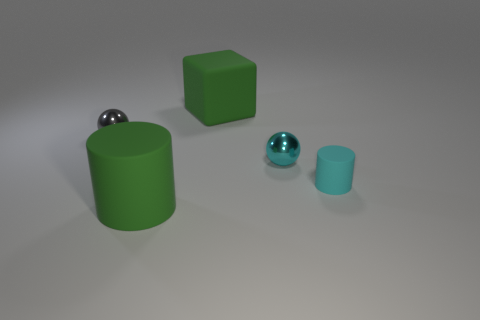Add 3 tiny yellow rubber blocks. How many objects exist? 8 Subtract all spheres. How many objects are left? 3 Subtract 1 balls. How many balls are left? 1 Add 3 small blue things. How many small blue things exist? 3 Subtract 0 brown cylinders. How many objects are left? 5 Subtract all gray spheres. Subtract all red cylinders. How many spheres are left? 1 Subtract all red cylinders. How many brown cubes are left? 0 Subtract all tiny metallic balls. Subtract all tiny gray shiny balls. How many objects are left? 2 Add 3 cylinders. How many cylinders are left? 5 